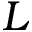<formula> <loc_0><loc_0><loc_500><loc_500>L</formula> 